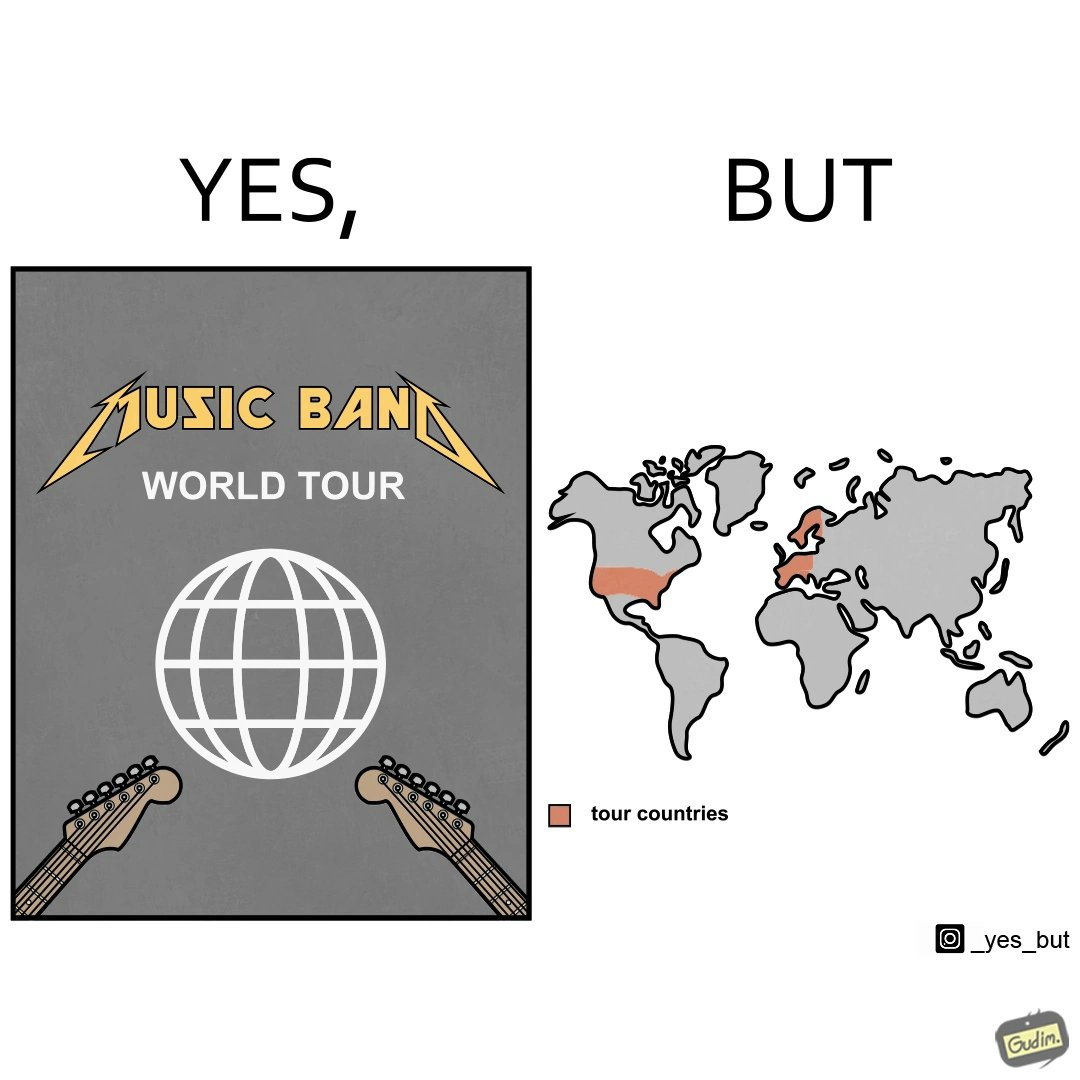Describe the satirical element in this image. The image is ironic, because in the first image some musical band is showing its poster of world tour but in the right image only a few countries are highlighted as tour countries 